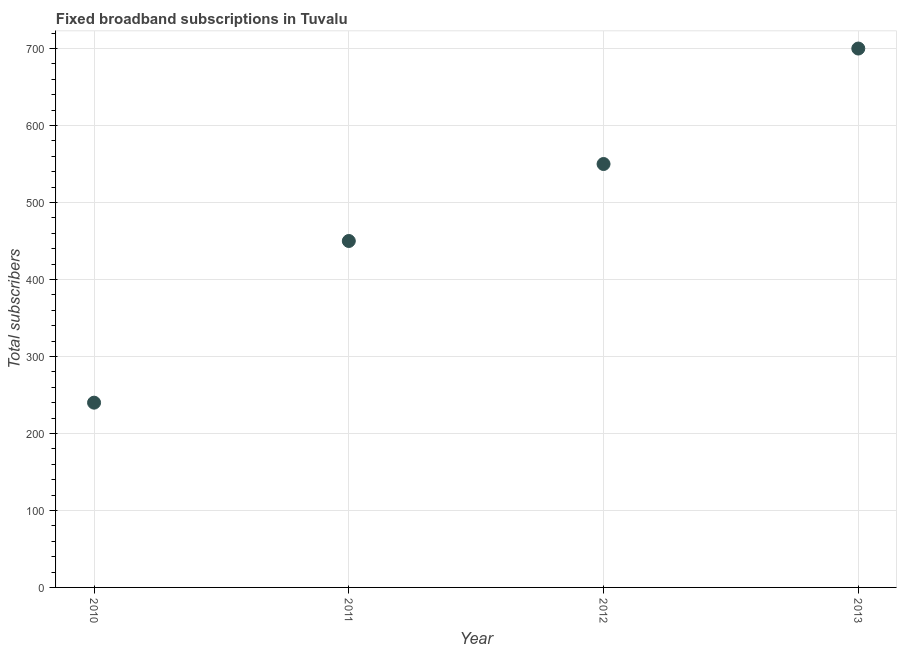What is the total number of fixed broadband subscriptions in 2013?
Give a very brief answer. 700. Across all years, what is the maximum total number of fixed broadband subscriptions?
Provide a succinct answer. 700. Across all years, what is the minimum total number of fixed broadband subscriptions?
Your answer should be compact. 240. What is the sum of the total number of fixed broadband subscriptions?
Your answer should be compact. 1940. What is the difference between the total number of fixed broadband subscriptions in 2010 and 2013?
Ensure brevity in your answer.  -460. What is the average total number of fixed broadband subscriptions per year?
Your answer should be compact. 485. What is the median total number of fixed broadband subscriptions?
Your response must be concise. 500. What is the ratio of the total number of fixed broadband subscriptions in 2012 to that in 2013?
Make the answer very short. 0.79. What is the difference between the highest and the second highest total number of fixed broadband subscriptions?
Offer a very short reply. 150. Is the sum of the total number of fixed broadband subscriptions in 2011 and 2013 greater than the maximum total number of fixed broadband subscriptions across all years?
Your response must be concise. Yes. What is the difference between the highest and the lowest total number of fixed broadband subscriptions?
Provide a succinct answer. 460. What is the difference between two consecutive major ticks on the Y-axis?
Ensure brevity in your answer.  100. Are the values on the major ticks of Y-axis written in scientific E-notation?
Your response must be concise. No. Does the graph contain any zero values?
Ensure brevity in your answer.  No. What is the title of the graph?
Make the answer very short. Fixed broadband subscriptions in Tuvalu. What is the label or title of the Y-axis?
Offer a very short reply. Total subscribers. What is the Total subscribers in 2010?
Make the answer very short. 240. What is the Total subscribers in 2011?
Provide a short and direct response. 450. What is the Total subscribers in 2012?
Offer a very short reply. 550. What is the Total subscribers in 2013?
Give a very brief answer. 700. What is the difference between the Total subscribers in 2010 and 2011?
Ensure brevity in your answer.  -210. What is the difference between the Total subscribers in 2010 and 2012?
Offer a terse response. -310. What is the difference between the Total subscribers in 2010 and 2013?
Provide a short and direct response. -460. What is the difference between the Total subscribers in 2011 and 2012?
Your response must be concise. -100. What is the difference between the Total subscribers in 2011 and 2013?
Offer a very short reply. -250. What is the difference between the Total subscribers in 2012 and 2013?
Offer a very short reply. -150. What is the ratio of the Total subscribers in 2010 to that in 2011?
Keep it short and to the point. 0.53. What is the ratio of the Total subscribers in 2010 to that in 2012?
Offer a very short reply. 0.44. What is the ratio of the Total subscribers in 2010 to that in 2013?
Ensure brevity in your answer.  0.34. What is the ratio of the Total subscribers in 2011 to that in 2012?
Provide a short and direct response. 0.82. What is the ratio of the Total subscribers in 2011 to that in 2013?
Offer a very short reply. 0.64. What is the ratio of the Total subscribers in 2012 to that in 2013?
Provide a succinct answer. 0.79. 